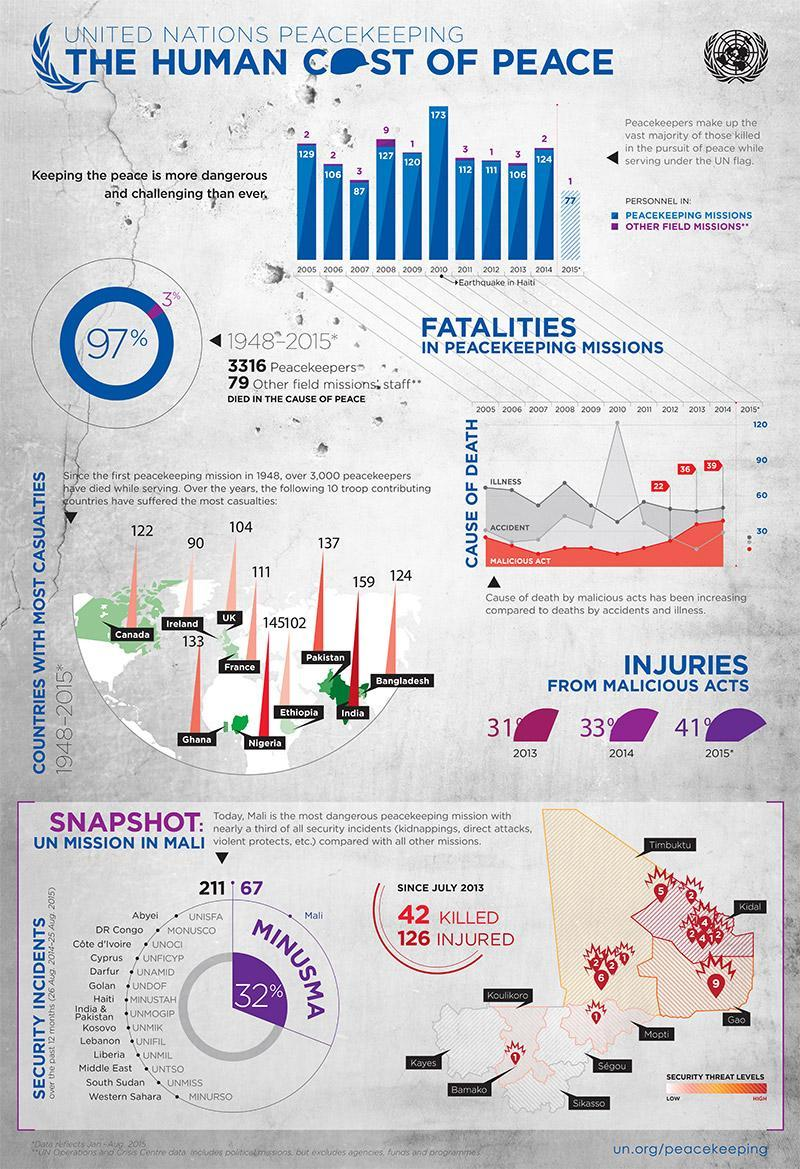How many personnels were deployed in the UN peacekeeping missions in 2012?
Answer the question with a short phrase. 111 Which country has reported highest number of casualties between 1948-2015? India How many personnels were deployed in the UN peacekeeping missions in 2009? 120 In which year, highest number of personnels were deployed in the UN peacekeeping missions between 2005-2015? 2010 How many personnels were deployed in other field missions by the UN in 2007? 3 In which year, highest number of personnels were deployed in the other field missions between 2005-2015? 2008 What percentage of personnels were deployed in the UN peacekeeping missions between 1948-2015? 97% What is the number of casualties reported in Bangladesh during 1948-2015? 124 Which country has reported least number of casualties between 1948-2015? Ireland What percentage of personnels were deployed in the other field missions during 1948-2015? 3% 